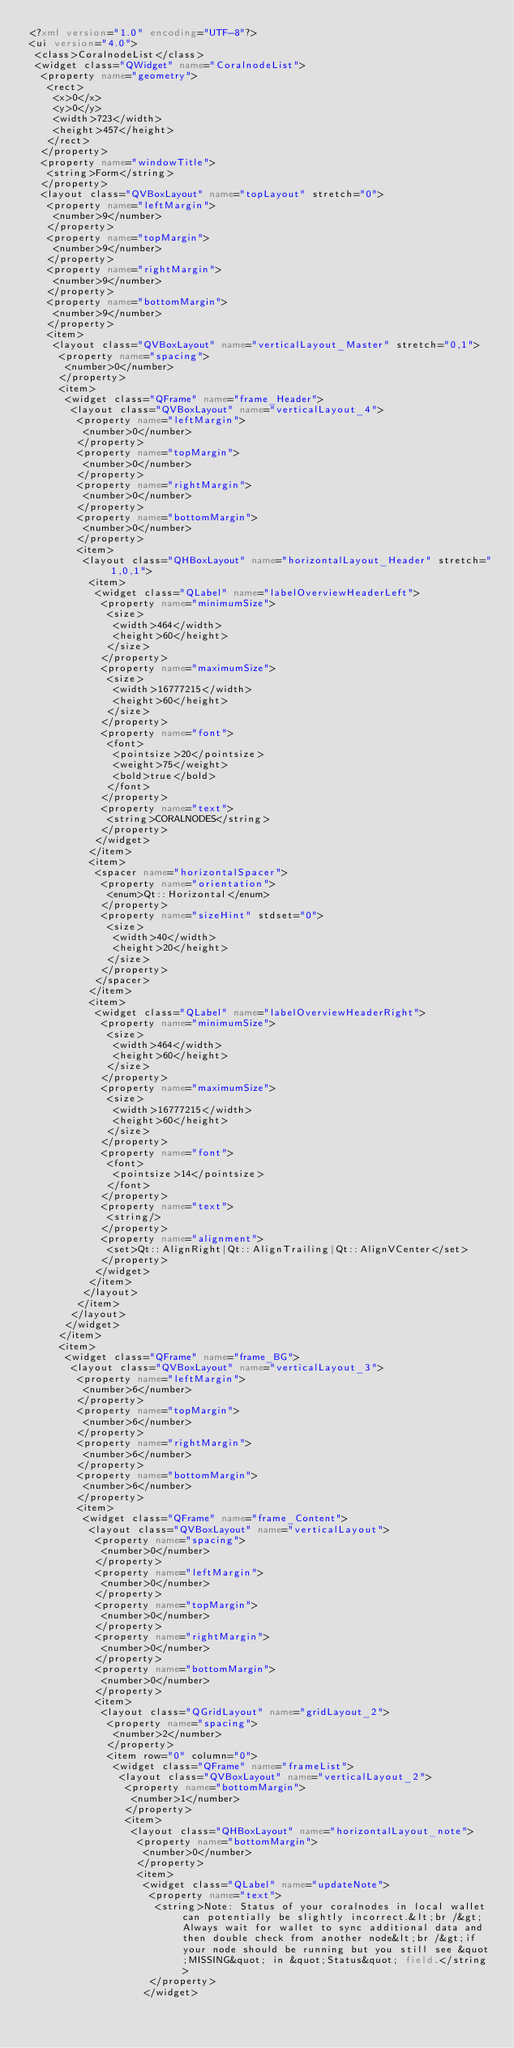<code> <loc_0><loc_0><loc_500><loc_500><_XML_><?xml version="1.0" encoding="UTF-8"?>
<ui version="4.0">
 <class>CoralnodeList</class>
 <widget class="QWidget" name="CoralnodeList">
  <property name="geometry">
   <rect>
    <x>0</x>
    <y>0</y>
    <width>723</width>
    <height>457</height>
   </rect>
  </property>
  <property name="windowTitle">
   <string>Form</string>
  </property>
  <layout class="QVBoxLayout" name="topLayout" stretch="0">
   <property name="leftMargin">
    <number>9</number>
   </property>
   <property name="topMargin">
    <number>9</number>
   </property>
   <property name="rightMargin">
    <number>9</number>
   </property>
   <property name="bottomMargin">
    <number>9</number>
   </property>
   <item>
    <layout class="QVBoxLayout" name="verticalLayout_Master" stretch="0,1">
     <property name="spacing">
      <number>0</number>
     </property>
     <item>
      <widget class="QFrame" name="frame_Header">
       <layout class="QVBoxLayout" name="verticalLayout_4">
        <property name="leftMargin">
         <number>0</number>
        </property>
        <property name="topMargin">
         <number>0</number>
        </property>
        <property name="rightMargin">
         <number>0</number>
        </property>
        <property name="bottomMargin">
         <number>0</number>
        </property>
        <item>
         <layout class="QHBoxLayout" name="horizontalLayout_Header" stretch="1,0,1">
          <item>
           <widget class="QLabel" name="labelOverviewHeaderLeft">
            <property name="minimumSize">
             <size>
              <width>464</width>
              <height>60</height>
             </size>
            </property>
            <property name="maximumSize">
             <size>
              <width>16777215</width>
              <height>60</height>
             </size>
            </property>
            <property name="font">
             <font>
              <pointsize>20</pointsize>
              <weight>75</weight>
              <bold>true</bold>
             </font>
            </property>
            <property name="text">
             <string>CORALNODES</string>
            </property>
           </widget>
          </item>
          <item>
           <spacer name="horizontalSpacer">
            <property name="orientation">
             <enum>Qt::Horizontal</enum>
            </property>
            <property name="sizeHint" stdset="0">
             <size>
              <width>40</width>
              <height>20</height>
             </size>
            </property>
           </spacer>
          </item>
          <item>
           <widget class="QLabel" name="labelOverviewHeaderRight">
            <property name="minimumSize">
             <size>
              <width>464</width>
              <height>60</height>
             </size>
            </property>
            <property name="maximumSize">
             <size>
              <width>16777215</width>
              <height>60</height>
             </size>
            </property>
            <property name="font">
             <font>
              <pointsize>14</pointsize>
             </font>
            </property>
            <property name="text">
             <string/>
            </property>
            <property name="alignment">
             <set>Qt::AlignRight|Qt::AlignTrailing|Qt::AlignVCenter</set>
            </property>
           </widget>
          </item>
         </layout>
        </item>
       </layout>
      </widget>
     </item>
     <item>
      <widget class="QFrame" name="frame_BG">
       <layout class="QVBoxLayout" name="verticalLayout_3">
        <property name="leftMargin">
         <number>6</number>
        </property>
        <property name="topMargin">
         <number>6</number>
        </property>
        <property name="rightMargin">
         <number>6</number>
        </property>
        <property name="bottomMargin">
         <number>6</number>
        </property>
        <item>
         <widget class="QFrame" name="frame_Content">
          <layout class="QVBoxLayout" name="verticalLayout">
           <property name="spacing">
            <number>0</number>
           </property>
           <property name="leftMargin">
            <number>0</number>
           </property>
           <property name="topMargin">
            <number>0</number>
           </property>
           <property name="rightMargin">
            <number>0</number>
           </property>
           <property name="bottomMargin">
            <number>0</number>
           </property>
           <item>
            <layout class="QGridLayout" name="gridLayout_2">
             <property name="spacing">
              <number>2</number>
             </property>
             <item row="0" column="0">
              <widget class="QFrame" name="frameList">
               <layout class="QVBoxLayout" name="verticalLayout_2">
                <property name="bottomMargin">
                 <number>1</number>
                </property>
                <item>
                 <layout class="QHBoxLayout" name="horizontalLayout_note">
                  <property name="bottomMargin">
                   <number>0</number>
                  </property>
                  <item>
                   <widget class="QLabel" name="updateNote">
                    <property name="text">
                     <string>Note: Status of your coralnodes in local wallet can potentially be slightly incorrect.&lt;br /&gt;Always wait for wallet to sync additional data and then double check from another node&lt;br /&gt;if your node should be running but you still see &quot;MISSING&quot; in &quot;Status&quot; field.</string>
                    </property>
                   </widget></code> 